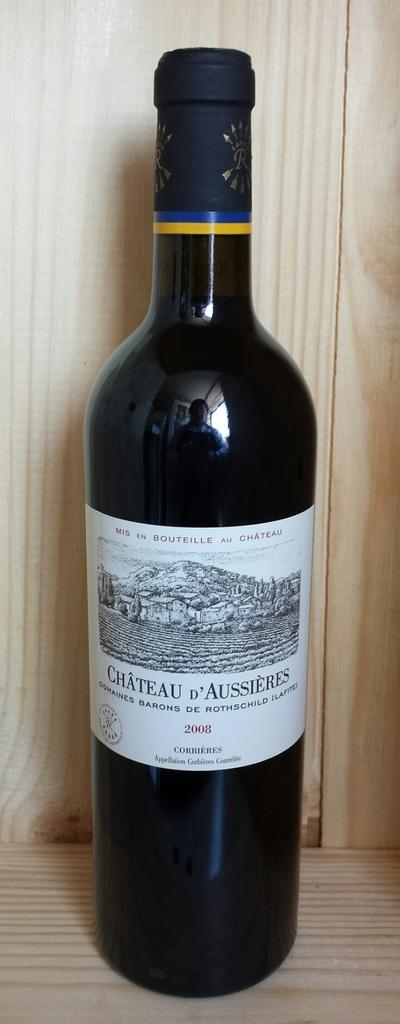<image>
Provide a brief description of the given image. a wine bottle that has the word Chateau on it 